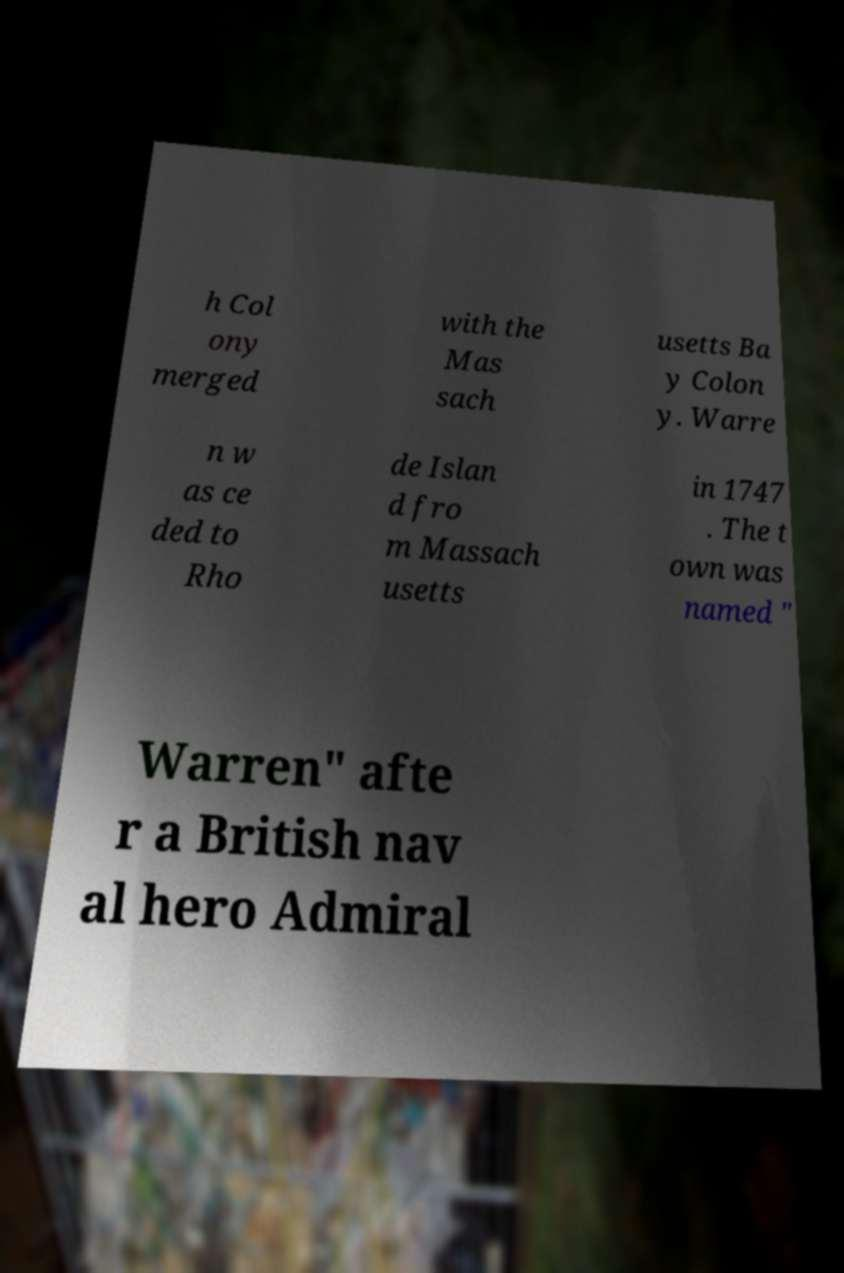For documentation purposes, I need the text within this image transcribed. Could you provide that? h Col ony merged with the Mas sach usetts Ba y Colon y. Warre n w as ce ded to Rho de Islan d fro m Massach usetts in 1747 . The t own was named " Warren" afte r a British nav al hero Admiral 